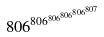Convert formula to latex. <formula><loc_0><loc_0><loc_500><loc_500>8 0 6 ^ { 8 0 6 ^ { 8 0 6 ^ { 8 0 6 ^ { 8 0 6 ^ { 8 0 7 } } } } }</formula> 